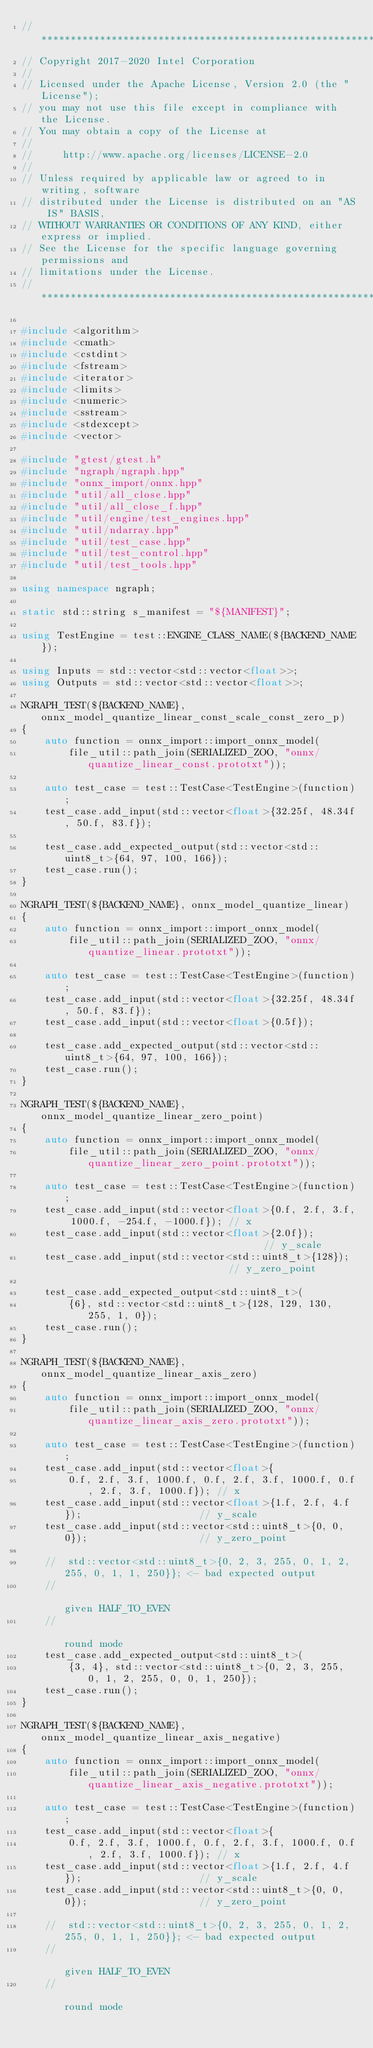<code> <loc_0><loc_0><loc_500><loc_500><_C++_>//*****************************************************************************
// Copyright 2017-2020 Intel Corporation
//
// Licensed under the Apache License, Version 2.0 (the "License");
// you may not use this file except in compliance with the License.
// You may obtain a copy of the License at
//
//     http://www.apache.org/licenses/LICENSE-2.0
//
// Unless required by applicable law or agreed to in writing, software
// distributed under the License is distributed on an "AS IS" BASIS,
// WITHOUT WARRANTIES OR CONDITIONS OF ANY KIND, either express or implied.
// See the License for the specific language governing permissions and
// limitations under the License.
//*****************************************************************************

#include <algorithm>
#include <cmath>
#include <cstdint>
#include <fstream>
#include <iterator>
#include <limits>
#include <numeric>
#include <sstream>
#include <stdexcept>
#include <vector>

#include "gtest/gtest.h"
#include "ngraph/ngraph.hpp"
#include "onnx_import/onnx.hpp"
#include "util/all_close.hpp"
#include "util/all_close_f.hpp"
#include "util/engine/test_engines.hpp"
#include "util/ndarray.hpp"
#include "util/test_case.hpp"
#include "util/test_control.hpp"
#include "util/test_tools.hpp"

using namespace ngraph;

static std::string s_manifest = "${MANIFEST}";

using TestEngine = test::ENGINE_CLASS_NAME(${BACKEND_NAME});

using Inputs = std::vector<std::vector<float>>;
using Outputs = std::vector<std::vector<float>>;

NGRAPH_TEST(${BACKEND_NAME}, onnx_model_quantize_linear_const_scale_const_zero_p)
{
    auto function = onnx_import::import_onnx_model(
        file_util::path_join(SERIALIZED_ZOO, "onnx/quantize_linear_const.prototxt"));

    auto test_case = test::TestCase<TestEngine>(function);
    test_case.add_input(std::vector<float>{32.25f, 48.34f, 50.f, 83.f});

    test_case.add_expected_output(std::vector<std::uint8_t>{64, 97, 100, 166});
    test_case.run();
}

NGRAPH_TEST(${BACKEND_NAME}, onnx_model_quantize_linear)
{
    auto function = onnx_import::import_onnx_model(
        file_util::path_join(SERIALIZED_ZOO, "onnx/quantize_linear.prototxt"));

    auto test_case = test::TestCase<TestEngine>(function);
    test_case.add_input(std::vector<float>{32.25f, 48.34f, 50.f, 83.f});
    test_case.add_input(std::vector<float>{0.5f});

    test_case.add_expected_output(std::vector<std::uint8_t>{64, 97, 100, 166});
    test_case.run();
}

NGRAPH_TEST(${BACKEND_NAME}, onnx_model_quantize_linear_zero_point)
{
    auto function = onnx_import::import_onnx_model(
        file_util::path_join(SERIALIZED_ZOO, "onnx/quantize_linear_zero_point.prototxt"));

    auto test_case = test::TestCase<TestEngine>(function);
    test_case.add_input(std::vector<float>{0.f, 2.f, 3.f, 1000.f, -254.f, -1000.f}); // x
    test_case.add_input(std::vector<float>{2.0f});                                   // y_scale
    test_case.add_input(std::vector<std::uint8_t>{128});                             // y_zero_point

    test_case.add_expected_output<std::uint8_t>(
        {6}, std::vector<std::uint8_t>{128, 129, 130, 255, 1, 0});
    test_case.run();
}

NGRAPH_TEST(${BACKEND_NAME}, onnx_model_quantize_linear_axis_zero)
{
    auto function = onnx_import::import_onnx_model(
        file_util::path_join(SERIALIZED_ZOO, "onnx/quantize_linear_axis_zero.prototxt"));

    auto test_case = test::TestCase<TestEngine>(function);
    test_case.add_input(std::vector<float>{
        0.f, 2.f, 3.f, 1000.f, 0.f, 2.f, 3.f, 1000.f, 0.f, 2.f, 3.f, 1000.f}); // x
    test_case.add_input(std::vector<float>{1.f, 2.f, 4.f});                    // y_scale
    test_case.add_input(std::vector<std::uint8_t>{0, 0, 0});                   // y_zero_point

    //  std::vector<std::uint8_t>{0, 2, 3, 255, 0, 1, 2, 255, 0, 1, 1, 250}}; <- bad expected output
    //                                                                           given HALF_TO_EVEN
    //                                                                           round mode
    test_case.add_expected_output<std::uint8_t>(
        {3, 4}, std::vector<std::uint8_t>{0, 2, 3, 255, 0, 1, 2, 255, 0, 0, 1, 250});
    test_case.run();
}

NGRAPH_TEST(${BACKEND_NAME}, onnx_model_quantize_linear_axis_negative)
{
    auto function = onnx_import::import_onnx_model(
        file_util::path_join(SERIALIZED_ZOO, "onnx/quantize_linear_axis_negative.prototxt"));

    auto test_case = test::TestCase<TestEngine>(function);
    test_case.add_input(std::vector<float>{
        0.f, 2.f, 3.f, 1000.f, 0.f, 2.f, 3.f, 1000.f, 0.f, 2.f, 3.f, 1000.f}); // x
    test_case.add_input(std::vector<float>{1.f, 2.f, 4.f});                    // y_scale
    test_case.add_input(std::vector<std::uint8_t>{0, 0, 0});                   // y_zero_point

    //  std::vector<std::uint8_t>{0, 2, 3, 255, 0, 1, 2, 255, 0, 1, 1, 250}}; <- bad expected output
    //                                                                           given HALF_TO_EVEN
    //                                                                           round mode</code> 